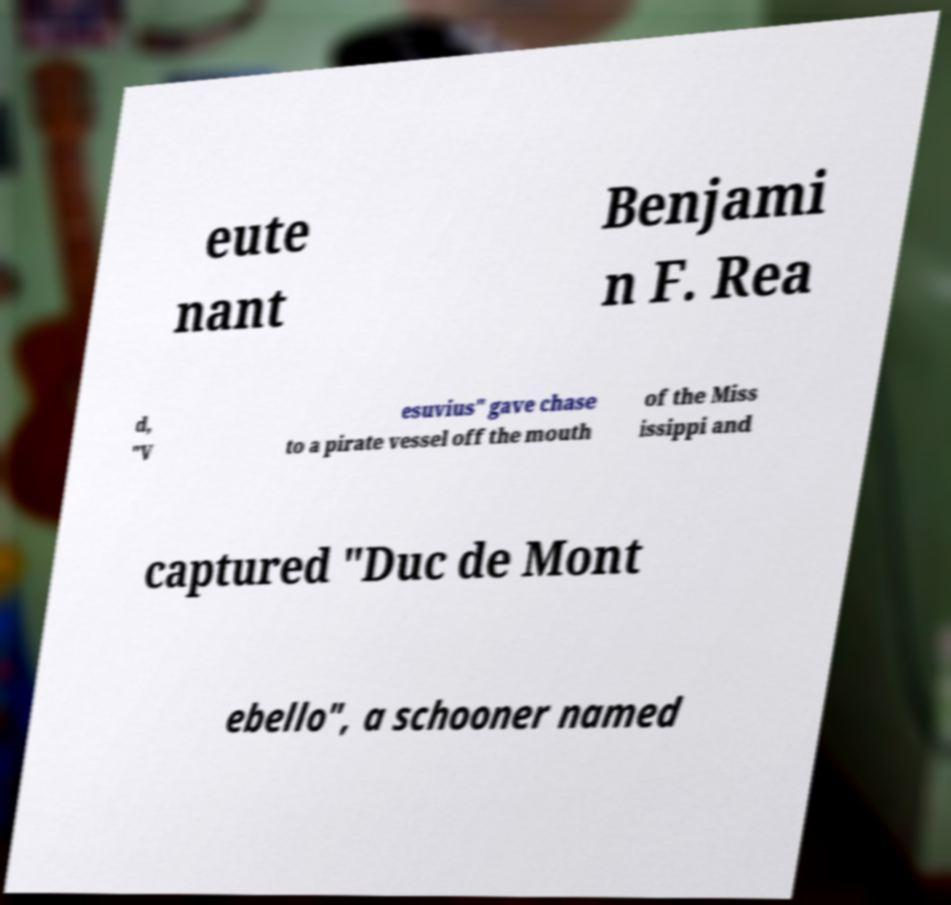Can you accurately transcribe the text from the provided image for me? eute nant Benjami n F. Rea d, "V esuvius" gave chase to a pirate vessel off the mouth of the Miss issippi and captured "Duc de Mont ebello", a schooner named 